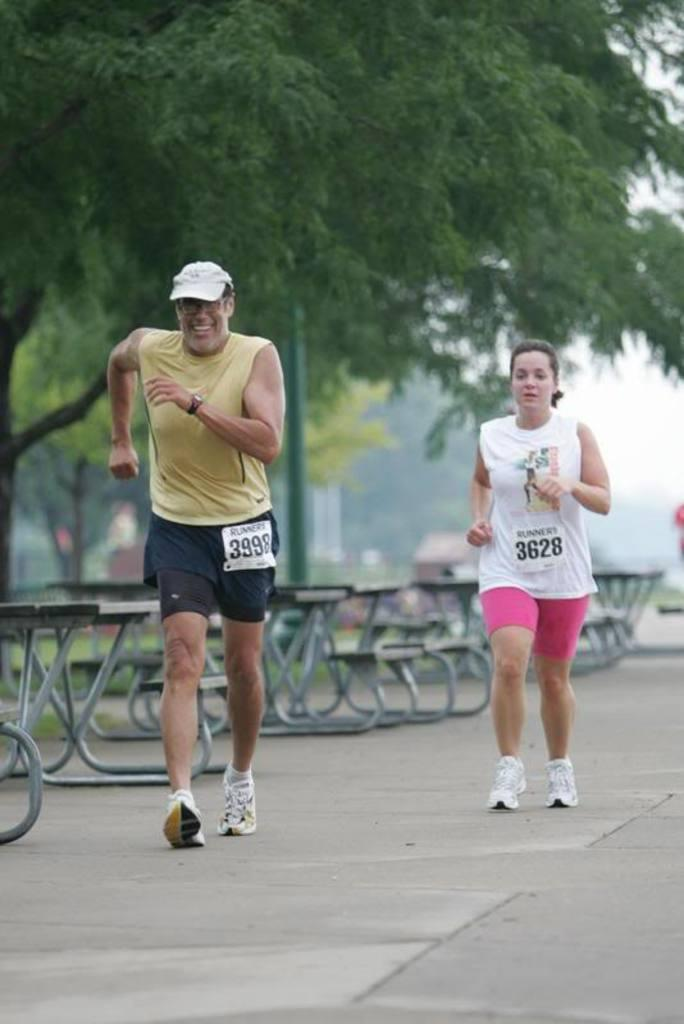How many people are present in the image? There are two people in the image. What type of seating is available in the image? There are benches in the image. What type of vegetation is present in the image? There are trees in the image. What is visible in the background of the image? There is a house in the background of the image. What part of the natural environment is visible in the image? The sky is visible in the image. How many giraffes are visible in the image? There are no giraffes present in the image. What type of bed is featured in the image? There is no bed present in the image. 